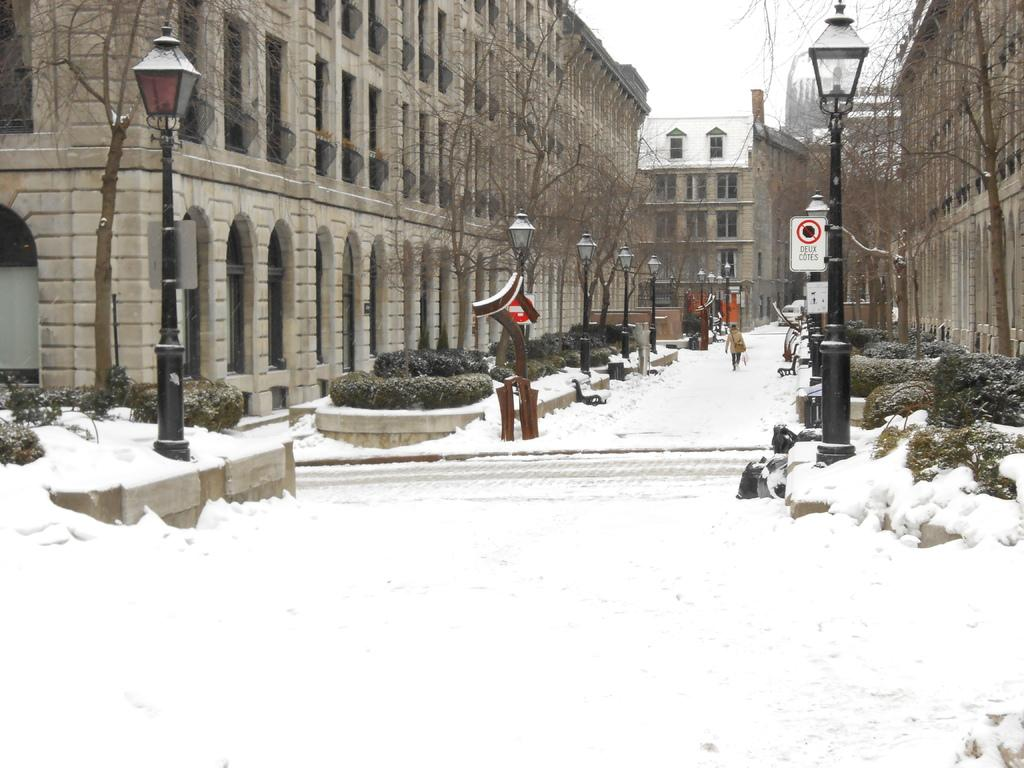What type of structures can be seen in the image? There is a group of buildings in the image. What else is present in the image besides the buildings? There are tree poles and a group of lights visible in the image. Can you describe the person in the image? There is a person standing in the snow in the background of the image. What can be seen in the sky in the image? The sky is visible in the background of the image. What type of snake can be seen slithering on the roof of the building in the image? There is no snake present in the image; it only features a group of buildings, tree poles, a group of lights, a person standing in the snow, and the sky. 